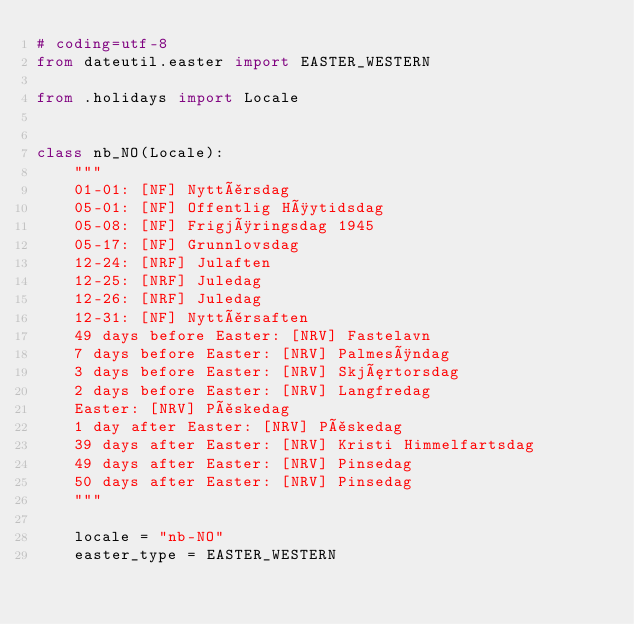Convert code to text. <code><loc_0><loc_0><loc_500><loc_500><_Python_># coding=utf-8
from dateutil.easter import EASTER_WESTERN

from .holidays import Locale


class nb_NO(Locale):
    """
    01-01: [NF] Nyttårsdag
    05-01: [NF] Offentlig Høytidsdag
    05-08: [NF] Frigjøringsdag 1945
    05-17: [NF] Grunnlovsdag
    12-24: [NRF] Julaften
    12-25: [NRF] Juledag
    12-26: [NRF] Juledag
    12-31: [NF] Nyttårsaften
    49 days before Easter: [NRV] Fastelavn
    7 days before Easter: [NRV] Palmesøndag
    3 days before Easter: [NRV] Skjærtorsdag
    2 days before Easter: [NRV] Langfredag
    Easter: [NRV] Påskedag
    1 day after Easter: [NRV] Påskedag
    39 days after Easter: [NRV] Kristi Himmelfartsdag
    49 days after Easter: [NRV] Pinsedag
    50 days after Easter: [NRV] Pinsedag
    """

    locale = "nb-NO"
    easter_type = EASTER_WESTERN
</code> 